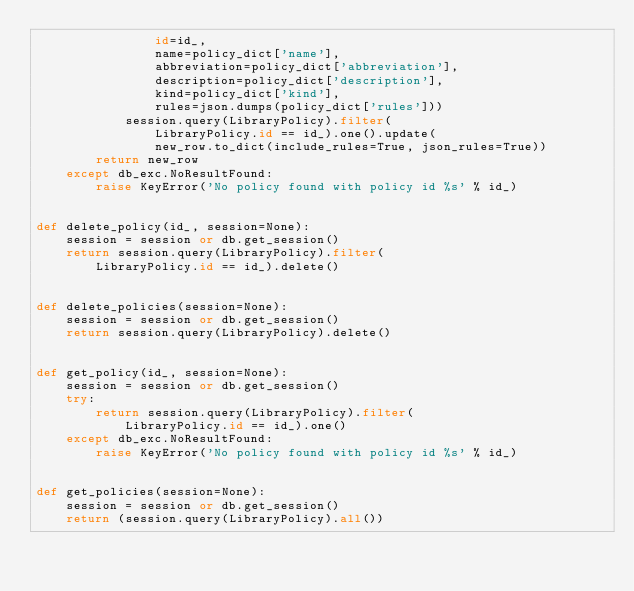<code> <loc_0><loc_0><loc_500><loc_500><_Python_>                id=id_,
                name=policy_dict['name'],
                abbreviation=policy_dict['abbreviation'],
                description=policy_dict['description'],
                kind=policy_dict['kind'],
                rules=json.dumps(policy_dict['rules']))
            session.query(LibraryPolicy).filter(
                LibraryPolicy.id == id_).one().update(
                new_row.to_dict(include_rules=True, json_rules=True))
        return new_row
    except db_exc.NoResultFound:
        raise KeyError('No policy found with policy id %s' % id_)


def delete_policy(id_, session=None):
    session = session or db.get_session()
    return session.query(LibraryPolicy).filter(
        LibraryPolicy.id == id_).delete()


def delete_policies(session=None):
    session = session or db.get_session()
    return session.query(LibraryPolicy).delete()


def get_policy(id_, session=None):
    session = session or db.get_session()
    try:
        return session.query(LibraryPolicy).filter(
            LibraryPolicy.id == id_).one()
    except db_exc.NoResultFound:
        raise KeyError('No policy found with policy id %s' % id_)


def get_policies(session=None):
    session = session or db.get_session()
    return (session.query(LibraryPolicy).all())
</code> 